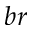Convert formula to latex. <formula><loc_0><loc_0><loc_500><loc_500>b r</formula> 